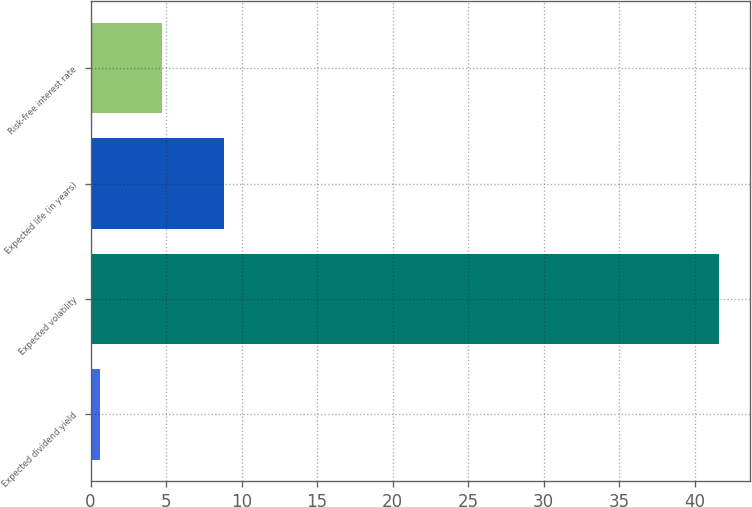<chart> <loc_0><loc_0><loc_500><loc_500><bar_chart><fcel>Expected dividend yield<fcel>Expected volatility<fcel>Expected life (in years)<fcel>Risk-free interest rate<nl><fcel>0.61<fcel>41.61<fcel>8.81<fcel>4.71<nl></chart> 